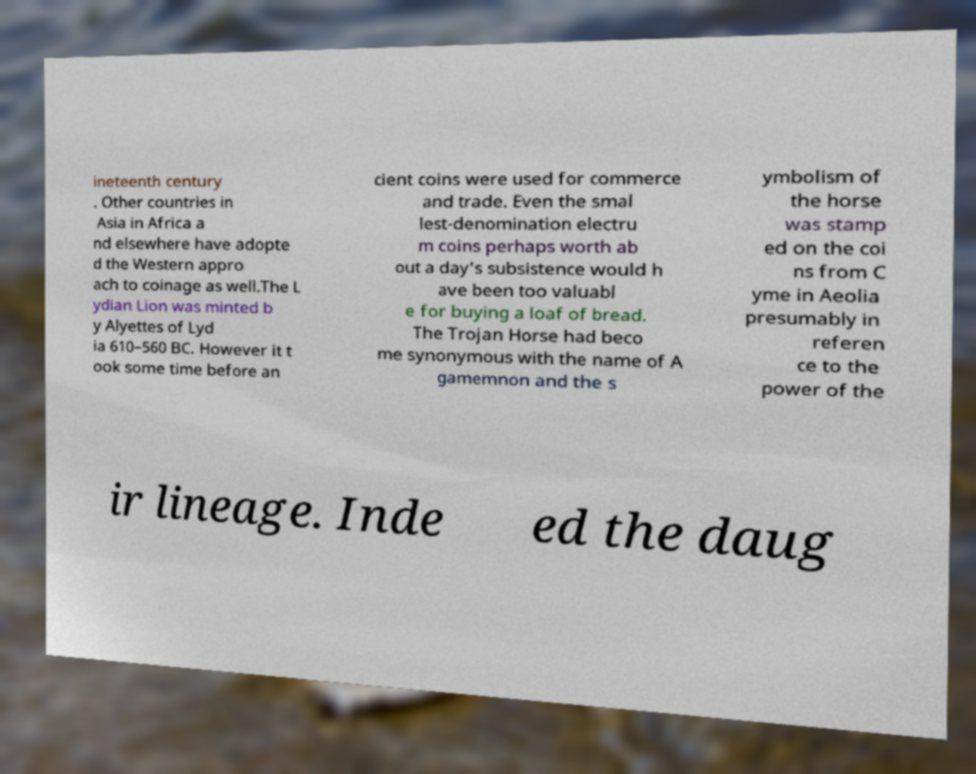For documentation purposes, I need the text within this image transcribed. Could you provide that? ineteenth century . Other countries in Asia in Africa a nd elsewhere have adopte d the Western appro ach to coinage as well.The L ydian Lion was minted b y Alyettes of Lyd ia 610–560 BC. However it t ook some time before an cient coins were used for commerce and trade. Even the smal lest-denomination electru m coins perhaps worth ab out a day's subsistence would h ave been too valuabl e for buying a loaf of bread. The Trojan Horse had beco me synonymous with the name of A gamemnon and the s ymbolism of the horse was stamp ed on the coi ns from C yme in Aeolia presumably in referen ce to the power of the ir lineage. Inde ed the daug 